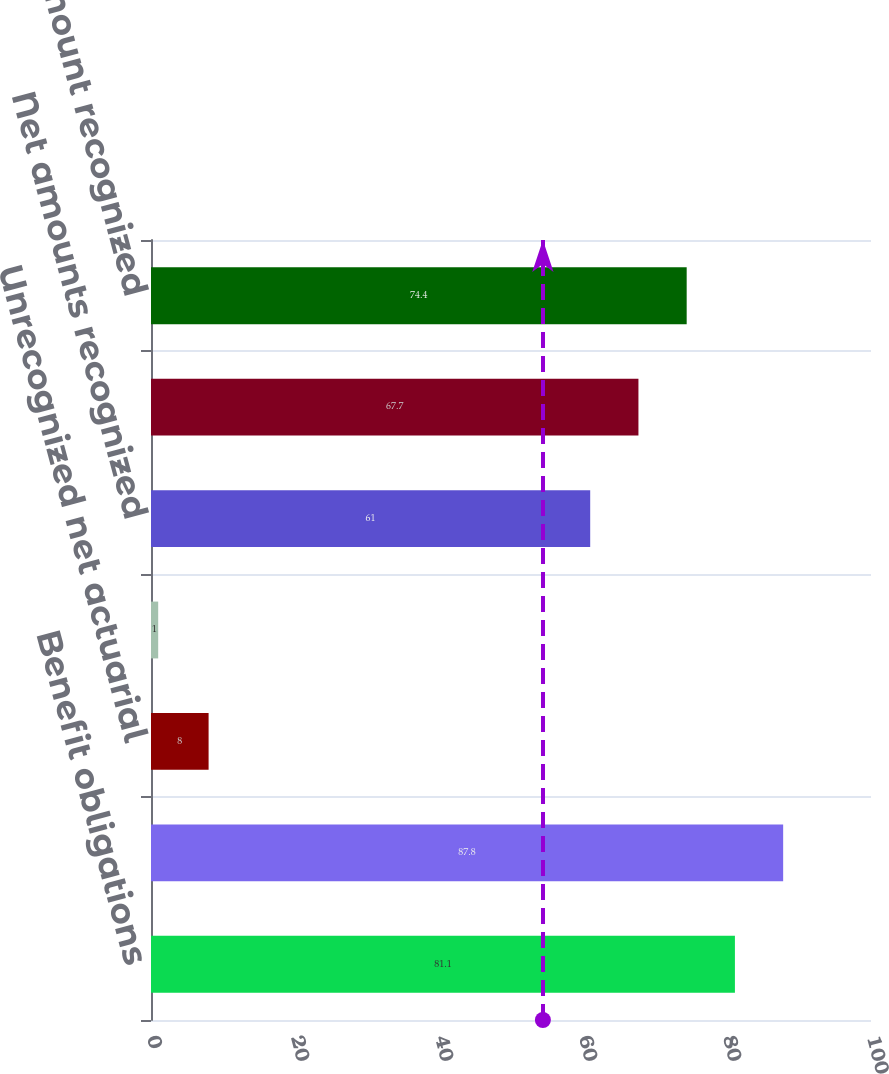Convert chart to OTSL. <chart><loc_0><loc_0><loc_500><loc_500><bar_chart><fcel>Benefit obligations<fcel>Funded status<fcel>Unrecognized net actuarial<fcel>Unrecognized prior service<fcel>Net amounts recognized<fcel>Accrued benefit cost<fcel>Net amount recognized<nl><fcel>81.1<fcel>87.8<fcel>8<fcel>1<fcel>61<fcel>67.7<fcel>74.4<nl></chart> 